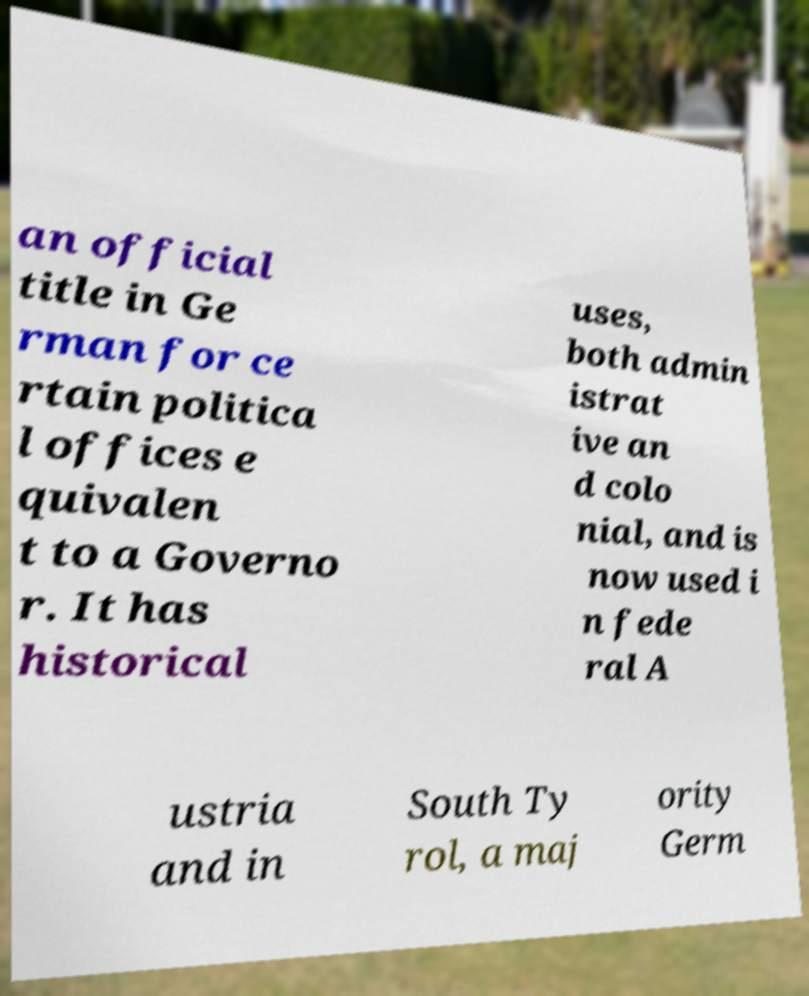There's text embedded in this image that I need extracted. Can you transcribe it verbatim? an official title in Ge rman for ce rtain politica l offices e quivalen t to a Governo r. It has historical uses, both admin istrat ive an d colo nial, and is now used i n fede ral A ustria and in South Ty rol, a maj ority Germ 